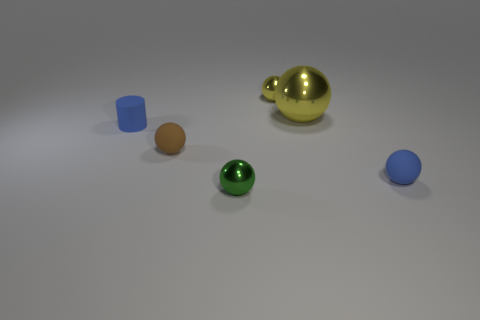Subtract 2 spheres. How many spheres are left? 3 Subtract all purple balls. Subtract all red cubes. How many balls are left? 5 Add 2 tiny rubber cylinders. How many objects exist? 8 Subtract all spheres. How many objects are left? 1 Add 6 matte objects. How many matte objects are left? 9 Add 5 green objects. How many green objects exist? 6 Subtract 0 green cubes. How many objects are left? 6 Subtract all tiny blue objects. Subtract all large green rubber blocks. How many objects are left? 4 